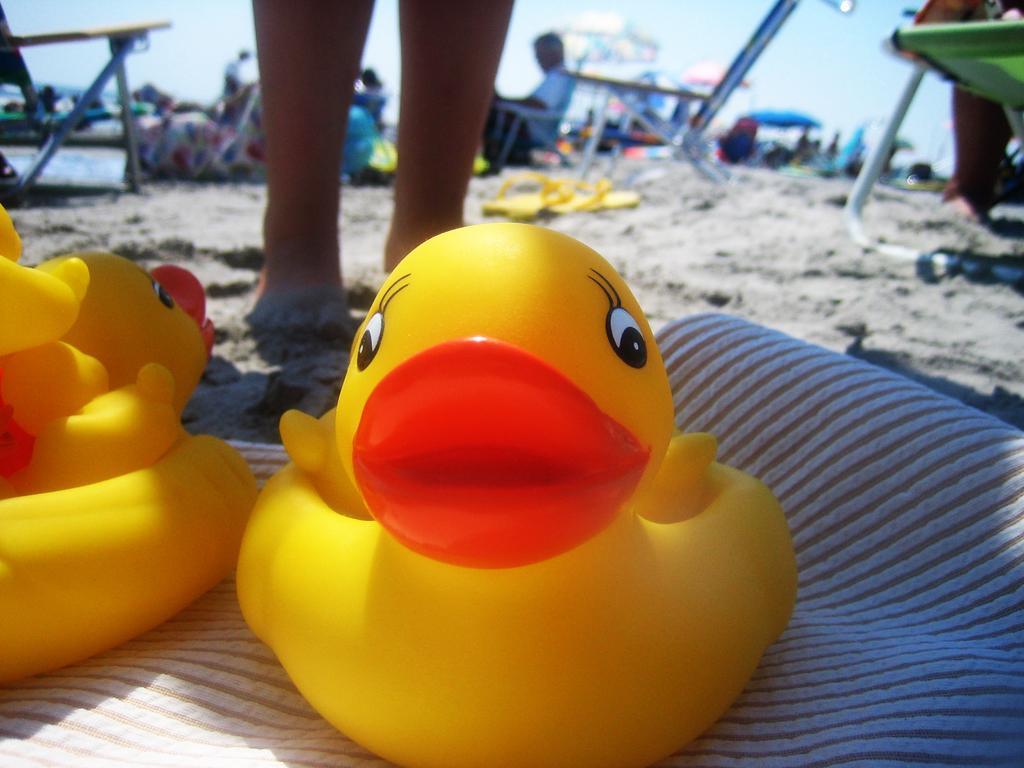Describe this image in one or two sentences. At the bottom of the picture, we see rubber ducks in yellow color. Behind that, we see the person standing. Beside the person, we see sand and yellow color slippers. We see tables. In the background, we see people sitting on the chairs. We even see umbrella tents. This picture is clicked at the beach. 